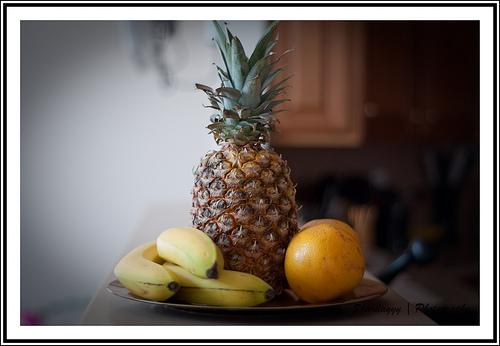What kind of tall fruit is in the center of the fruit plate? pineapple 